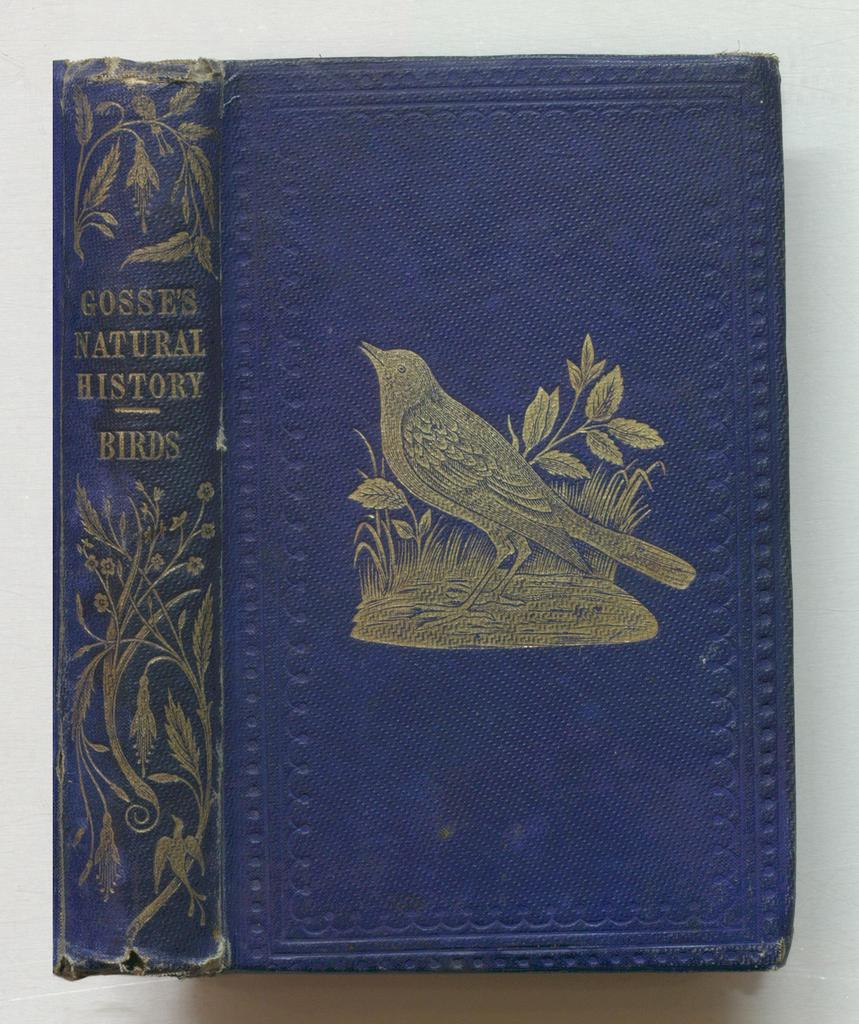<image>
Present a compact description of the photo's key features. A book titled Gosse's Natural History on birds with a bird on the blue cover. 